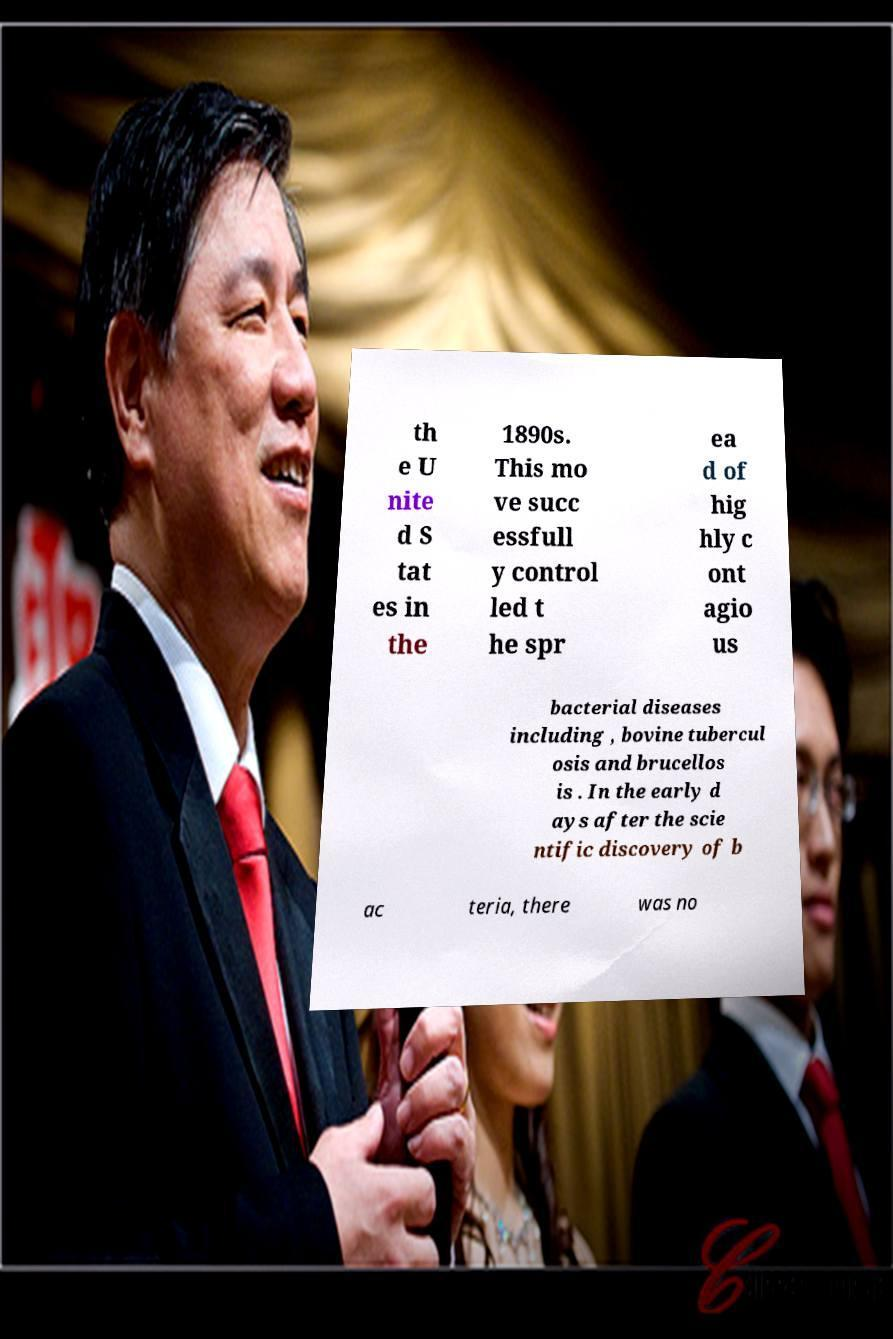I need the written content from this picture converted into text. Can you do that? th e U nite d S tat es in the 1890s. This mo ve succ essfull y control led t he spr ea d of hig hly c ont agio us bacterial diseases including , bovine tubercul osis and brucellos is . In the early d ays after the scie ntific discovery of b ac teria, there was no 